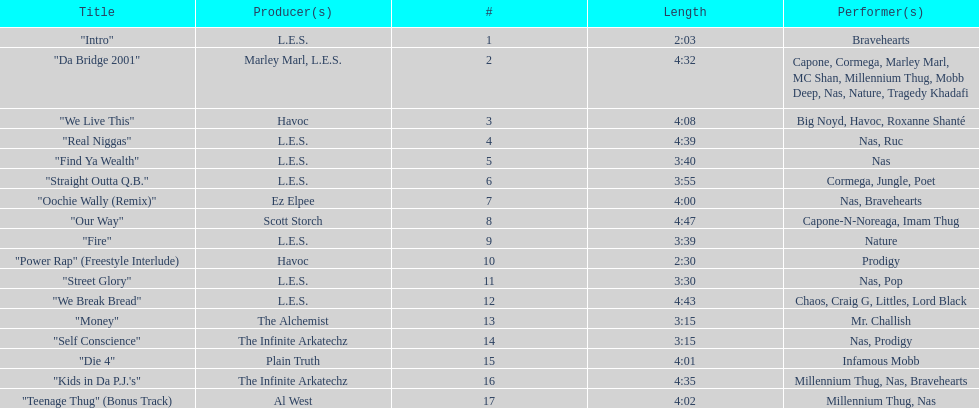Who produced the last track of the album? Al West. 